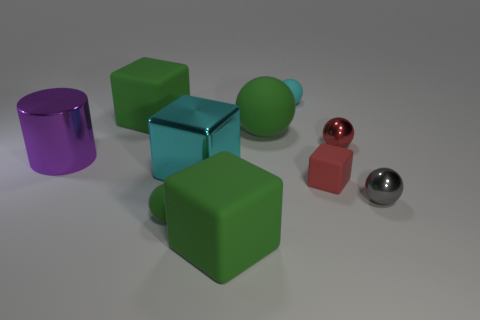What is the size of the ball that is the same color as the small rubber cube?
Offer a very short reply. Small. The metallic block that is the same size as the purple shiny cylinder is what color?
Offer a very short reply. Cyan. What number of matte things are balls or green things?
Your response must be concise. 5. The large cylinder that is made of the same material as the tiny gray thing is what color?
Ensure brevity in your answer.  Purple. What material is the large green block that is in front of the small red cube on the right side of the big cyan metallic object made of?
Offer a very short reply. Rubber. How many objects are either rubber blocks behind the big purple metal cylinder or large purple cylinders that are behind the big cyan metallic block?
Your answer should be compact. 2. There is a matte sphere behind the green thing that is behind the green rubber ball that is on the right side of the tiny green matte object; how big is it?
Give a very brief answer. Small. Are there an equal number of green matte cubes that are on the right side of the big green rubber ball and cyan matte things?
Give a very brief answer. No. Is there anything else that is the same shape as the red metal object?
Provide a short and direct response. Yes. Does the large purple object have the same shape as the green rubber object in front of the tiny green rubber object?
Keep it short and to the point. No. 